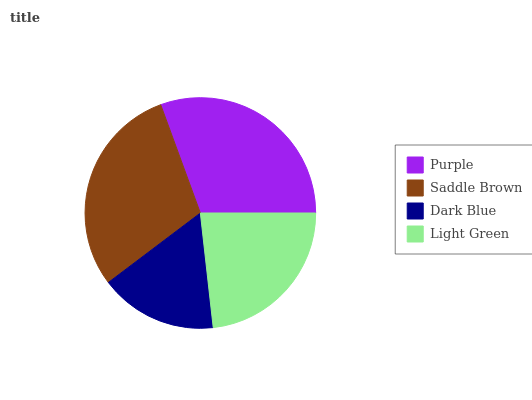Is Dark Blue the minimum?
Answer yes or no. Yes. Is Purple the maximum?
Answer yes or no. Yes. Is Saddle Brown the minimum?
Answer yes or no. No. Is Saddle Brown the maximum?
Answer yes or no. No. Is Purple greater than Saddle Brown?
Answer yes or no. Yes. Is Saddle Brown less than Purple?
Answer yes or no. Yes. Is Saddle Brown greater than Purple?
Answer yes or no. No. Is Purple less than Saddle Brown?
Answer yes or no. No. Is Saddle Brown the high median?
Answer yes or no. Yes. Is Light Green the low median?
Answer yes or no. Yes. Is Purple the high median?
Answer yes or no. No. Is Purple the low median?
Answer yes or no. No. 